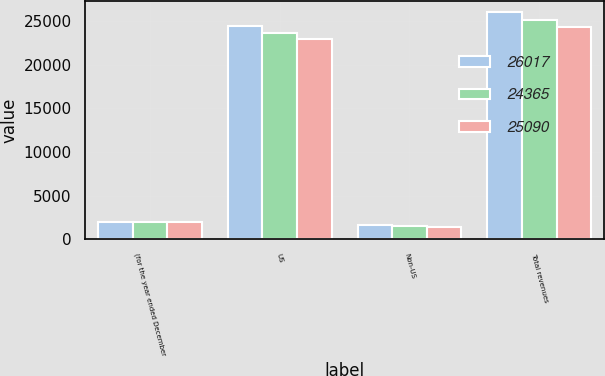Convert chart. <chart><loc_0><loc_0><loc_500><loc_500><stacked_bar_chart><ecel><fcel>(for the year ended December<fcel>US<fcel>Non-US<fcel>Total revenues<nl><fcel>26017<fcel>2007<fcel>24413<fcel>1604<fcel>26017<nl><fcel>24365<fcel>2006<fcel>23588<fcel>1502<fcel>25090<nl><fcel>25090<fcel>2005<fcel>22908<fcel>1457<fcel>24365<nl></chart> 